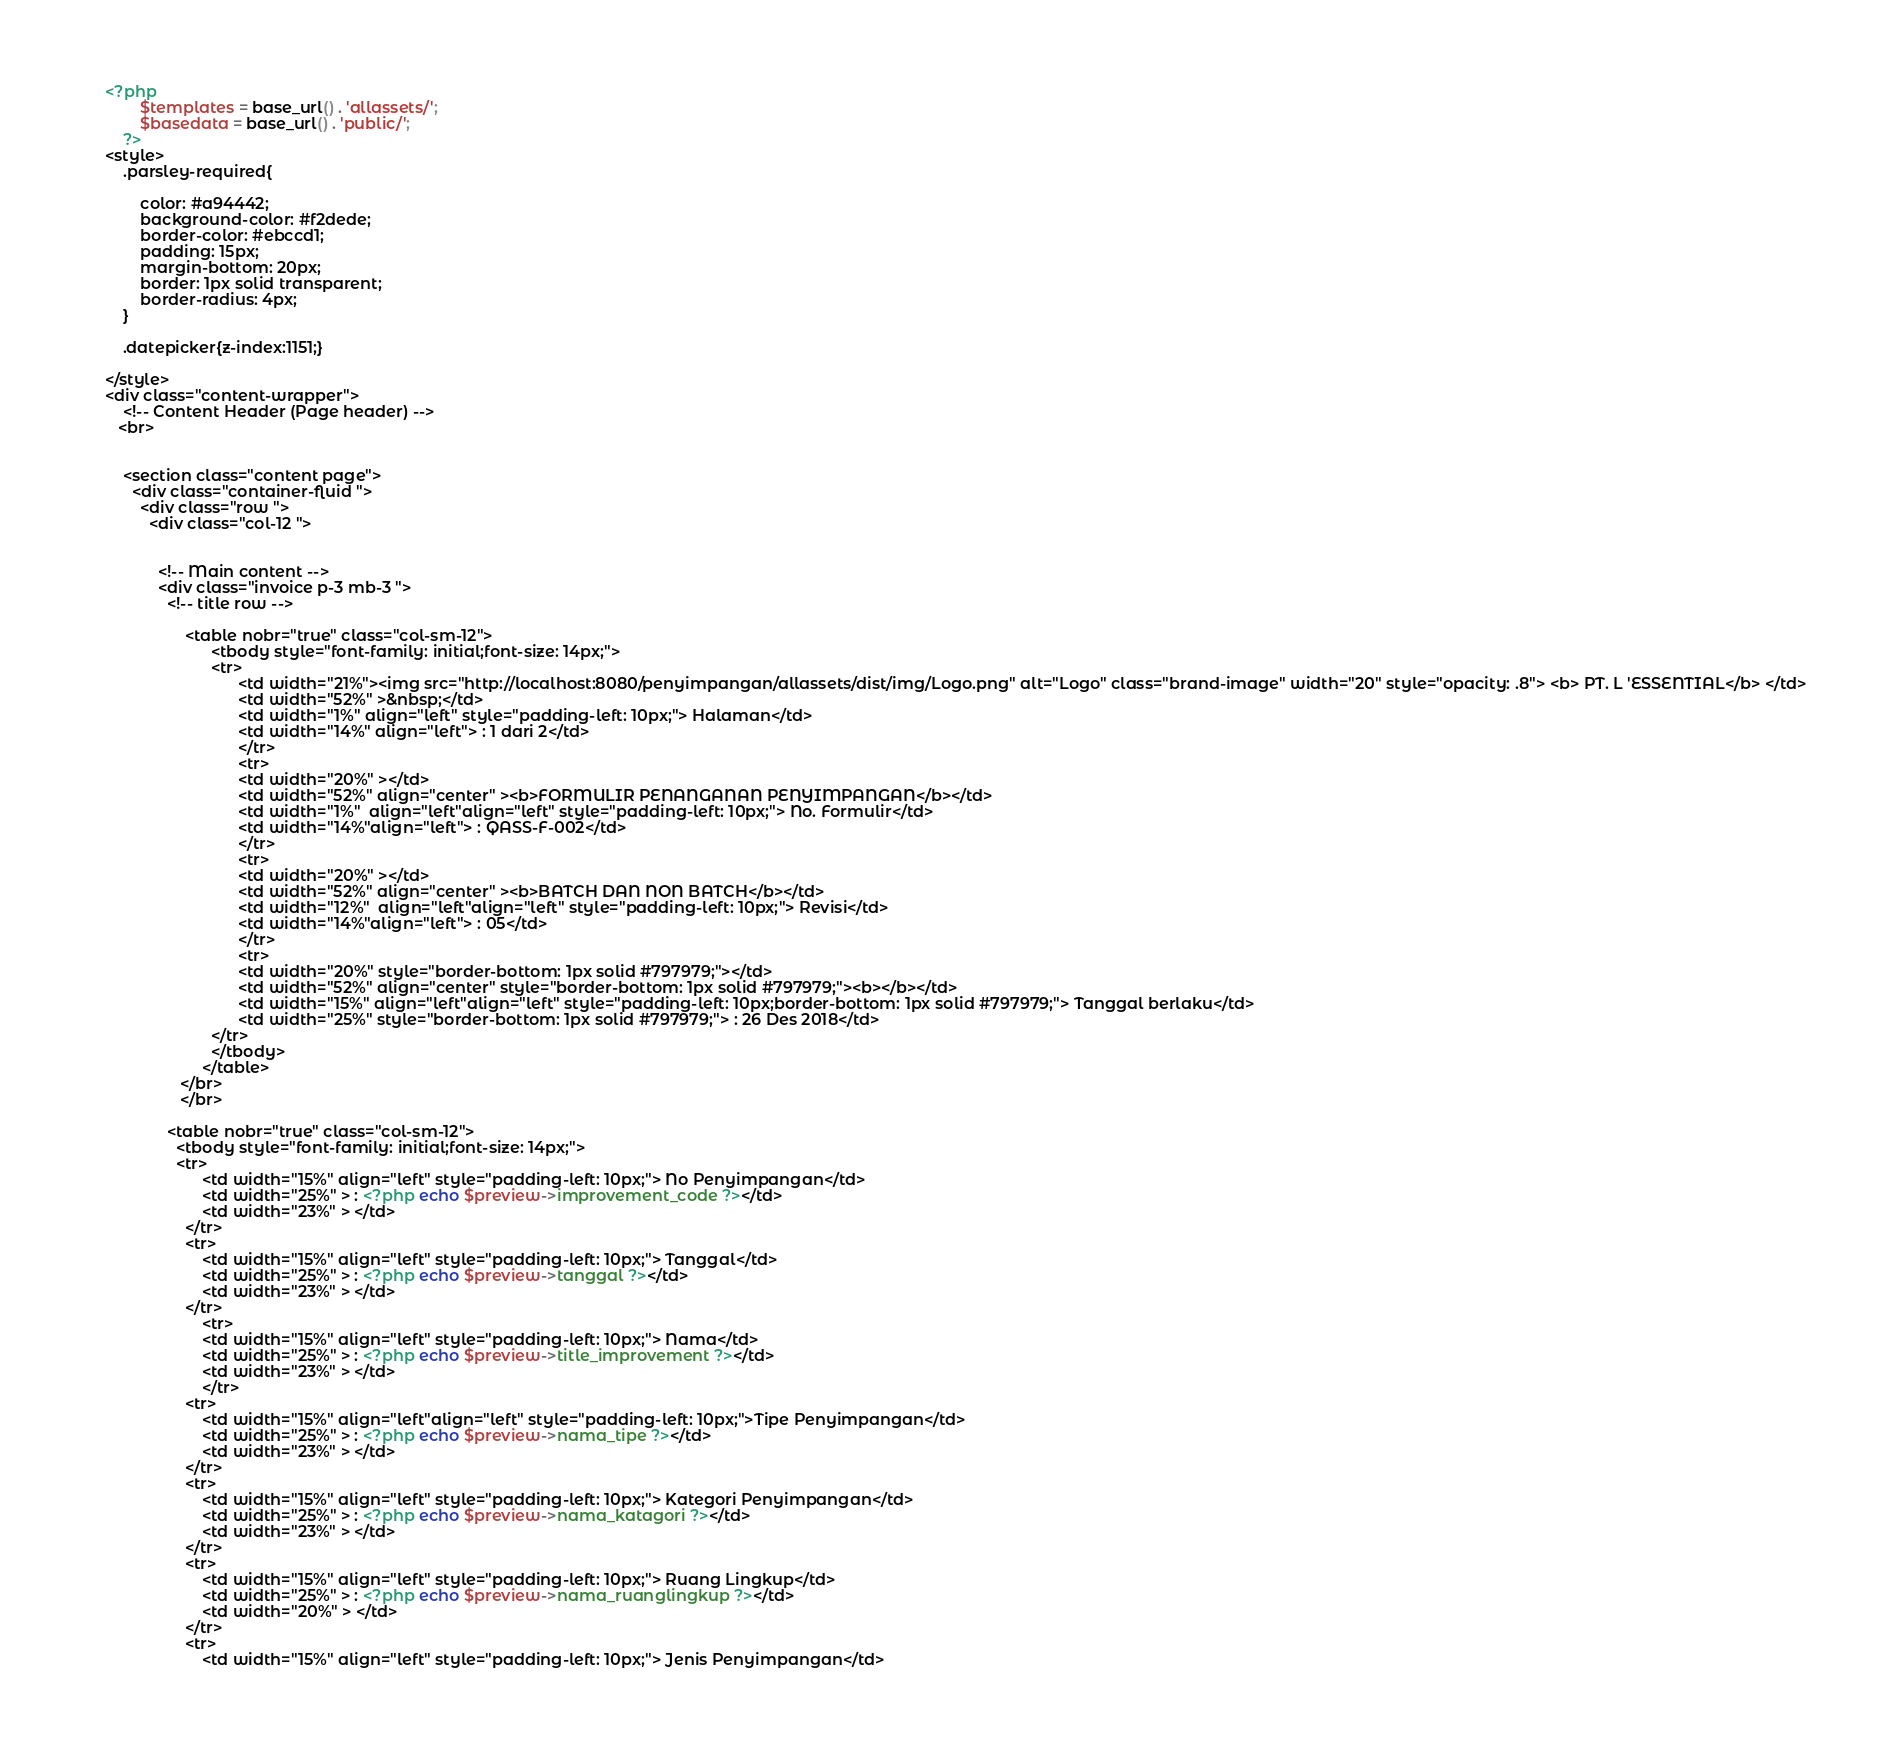<code> <loc_0><loc_0><loc_500><loc_500><_PHP_><?php 
        $templates = base_url() . 'allassets/';
        $basedata = base_url() . 'public/';
    ?>
<style>
    .parsley-required{

        color: #a94442;
        background-color: #f2dede;
        border-color: #ebccd1;
        padding: 15px;
        margin-bottom: 20px;
        border: 1px solid transparent;
        border-radius: 4px;
    }

    .datepicker{z-index:1151;}

</style>  
<div class="content-wrapper">
    <!-- Content Header (Page header) -->
   <br>


    <section class="content page">
      <div class="container-fluid ">
        <div class="row ">
          <div class="col-12 ">


            <!-- Main content -->
            <div class="invoice p-3 mb-3 ">
              <!-- title row -->
            
                  <table nobr="true" class="col-sm-12">
                        <tbody style="font-family: initial;font-size: 14px;">
                        <tr>
                              <td width="21%"><img src="http://localhost:8080/penyimpangan/allassets/dist/img/Logo.png" alt="Logo" class="brand-image" width="20" style="opacity: .8"> <b> PT. L 'ESSENTIAL</b> </td>
                              <td width="52%" >&nbsp;</td>
                              <td width="1%" align="left" style="padding-left: 10px;"> Halaman</td>
                              <td width="14%" align="left"> : 1 dari 2</td>
                              </tr>
                              <tr>
                              <td width="20%" ></td>
                              <td width="52%" align="center" ><b>FORMULIR PENANGANAN PENYIMPANGAN</b></td>
                              <td width="1%"  align="left"align="left" style="padding-left: 10px;"> No. Formulir</td>
                              <td width="14%"align="left"> : QASS-F-002</td>
                              </tr>
                              <tr>
                              <td width="20%" ></td>
                              <td width="52%" align="center" ><b>BATCH DAN NON BATCH</b></td>
                              <td width="12%"  align="left"align="left" style="padding-left: 10px;"> Revisi</td>
                              <td width="14%"align="left"> : 05</td>
                              </tr>
                              <tr>
                              <td width="20%" style="border-bottom: 1px solid #797979;"></td>
                              <td width="52%" align="center" style="border-bottom: 1px solid #797979;"><b></b></td>
                              <td width="15%" align="left"align="left" style="padding-left: 10px;border-bottom: 1px solid #797979;"> Tanggal berlaku</td>
                              <td width="25%" style="border-bottom: 1px solid #797979;"> : 26 Des 2018</td>
                        </tr>
                        </tbody>
                      </table>
                 </br>
                 </br>
                 
              <table nobr="true" class="col-sm-12">
                <tbody style="font-family: initial;font-size: 14px;">
                <tr>
                      <td width="15%" align="left" style="padding-left: 10px;"> No Penyimpangan</td>
                      <td width="25%" > : <?php echo $preview->improvement_code ?></td>
                      <td width="23%" > </td>
                  </tr>
                  <tr>
                      <td width="15%" align="left" style="padding-left: 10px;"> Tanggal</td>
                      <td width="25%" > : <?php echo $preview->tanggal ?></td>
                      <td width="23%" > </td>
                  </tr>
                      <tr>
                      <td width="15%" align="left" style="padding-left: 10px;"> Nama</td>
                      <td width="25%" > : <?php echo $preview->title_improvement ?></td>
                      <td width="23%" > </td>
                      </tr>
                  <tr>
                      <td width="15%" align="left"align="left" style="padding-left: 10px;">Tipe Penyimpangan</td>
                      <td width="25%" > : <?php echo $preview->nama_tipe ?></td>
                      <td width="23%" > </td>
                  </tr>
                  <tr>
                      <td width="15%" align="left" style="padding-left: 10px;"> Kategori Penyimpangan</td>
                      <td width="25%" > : <?php echo $preview->nama_katagori ?></td>
                      <td width="23%" > </td>
                  </tr>
                  <tr>
                      <td width="15%" align="left" style="padding-left: 10px;"> Ruang Lingkup</td>
                      <td width="25%" > : <?php echo $preview->nama_ruanglingkup ?></td>
                      <td width="20%" > </td>
                  </tr>
                  <tr>
                      <td width="15%" align="left" style="padding-left: 10px;"> Jenis Penyimpangan</td></code> 